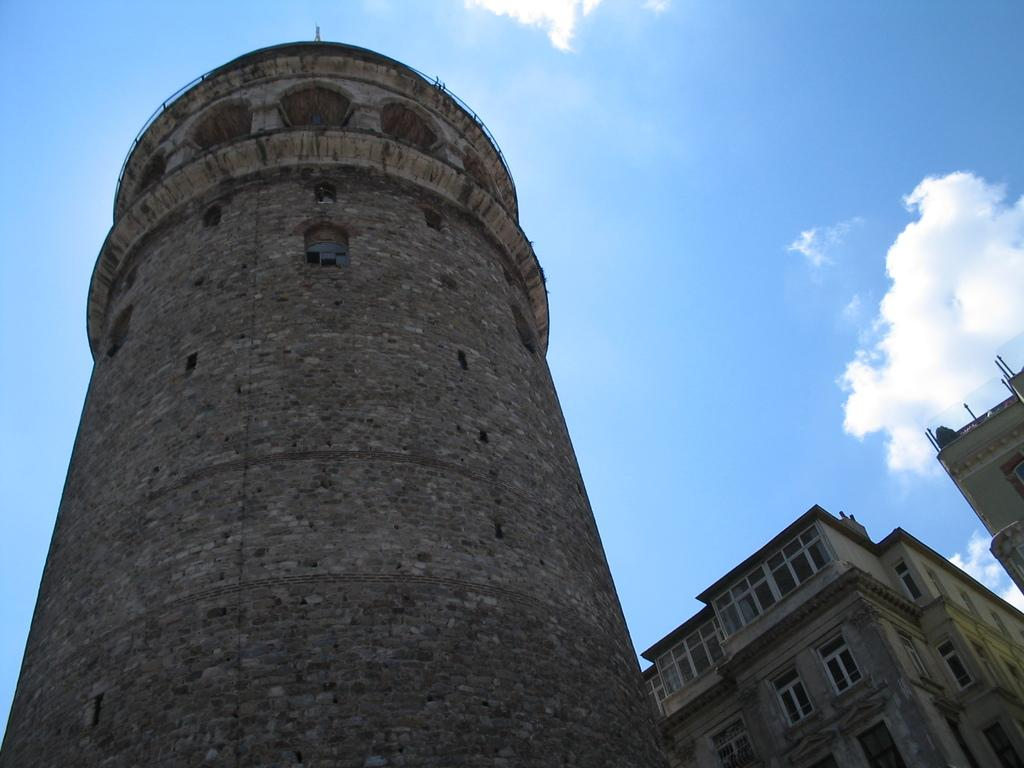What type of structure is visible in the image? There is a tall brick wall in the image. What can be seen at the bottom of the image? The image shows houses from the bottom. What color is the sky in the image? The sky is blue in the image. Can you see the elbow of the person taking the picture in the image? There is no person visible in the image, so it is not possible to see their elbow. 